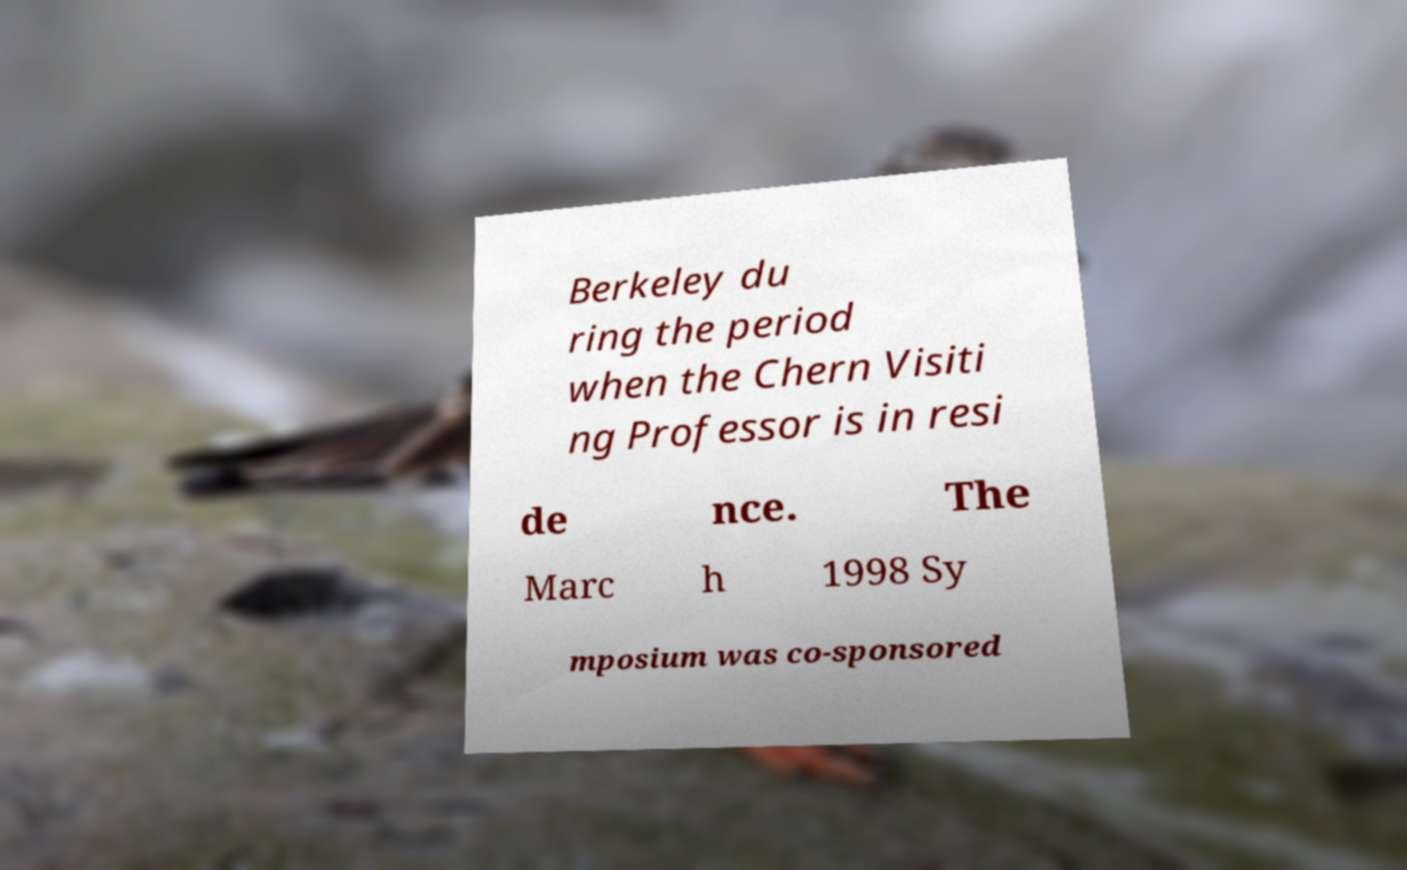There's text embedded in this image that I need extracted. Can you transcribe it verbatim? Berkeley du ring the period when the Chern Visiti ng Professor is in resi de nce. The Marc h 1998 Sy mposium was co-sponsored 